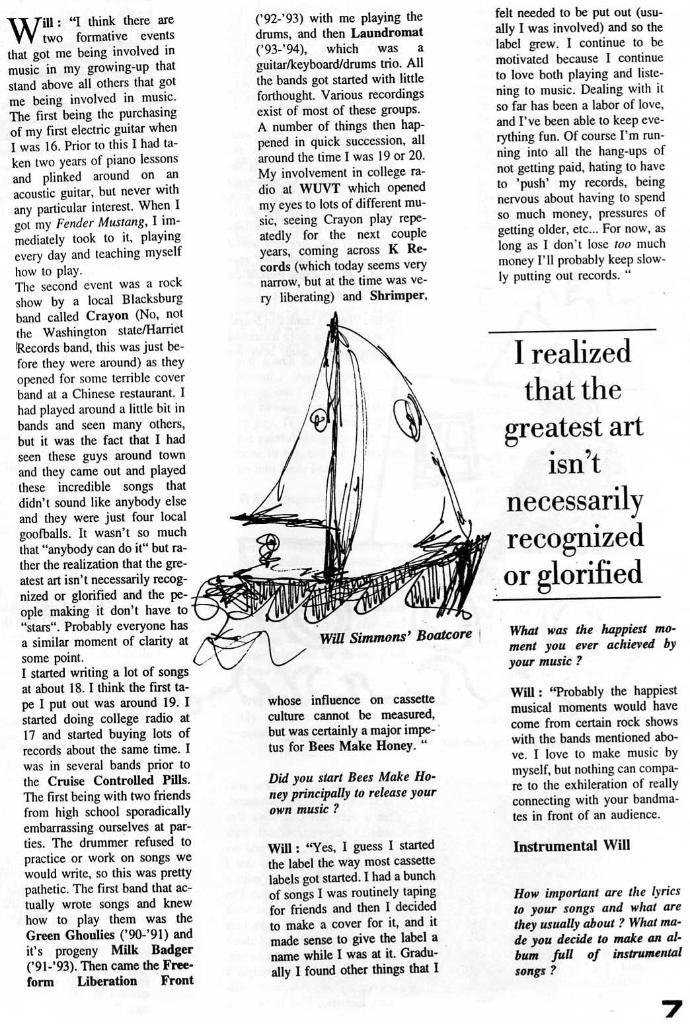What can be found in the image that contains written information? There is text in the image. What type of visual element is present in the image? There is an art piece in the image. What type of drink is being served in the image? There is no drink present in the image; it only contains text and an art piece. What type of writing instrument is being used in the image? There is no writing instrument visible in the image. 